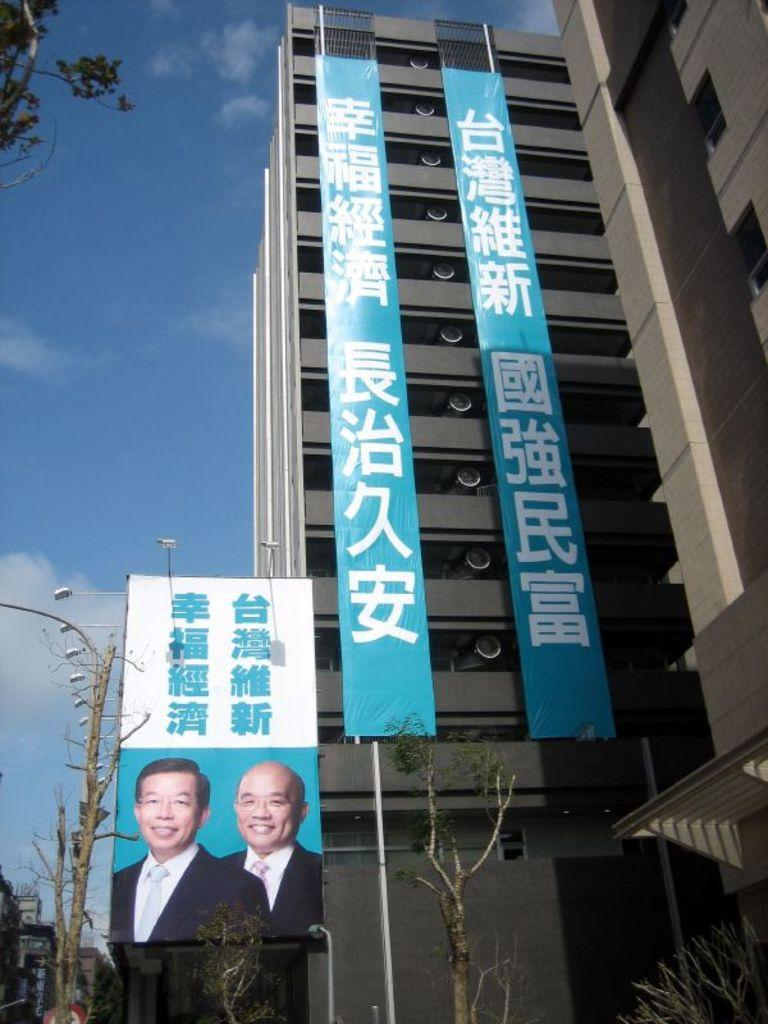What type of structures can be seen in the image? There are buildings in the image. What objects are present in the image besides the buildings? There are boards and poles visible in the image. What can be seen in the background of the image? There are trees and the sky visible in the background of the image. Where is the lunchroom located in the image? There is no lunchroom present in the image. Can you hear any sounds coming from the ear in the image? There is no ear present in the image. 